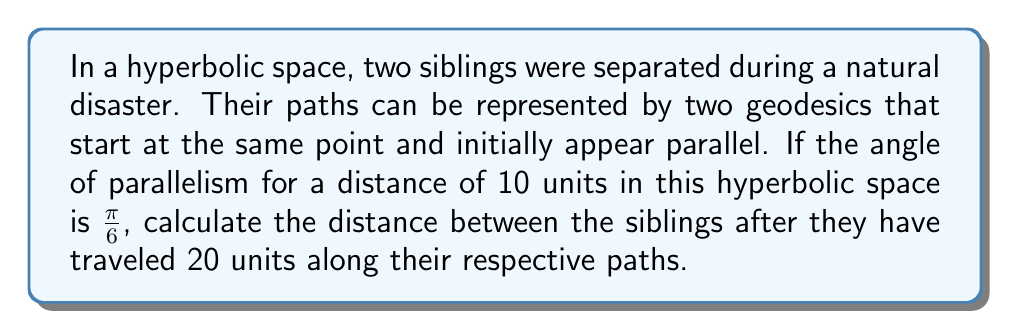Can you answer this question? Let's approach this step-by-step:

1) In hyperbolic geometry, the angle of parallelism $\Pi(d)$ for a distance $d$ is given by the formula:

   $$\Pi(d) = 2 \arctan(e^{-d})$$

2) We're given that $\Pi(10) = \frac{\pi}{6}$. Let's use this to find the curvature of our hyperbolic space:

   $$\frac{\pi}{6} = 2 \arctan(e^{-10k})$$

   Where $k$ is the curvature.

3) Solving this equation:

   $$\tan(\frac{\pi}{12}) = e^{-10k}$$
   $$k = -\frac{1}{10} \ln(\tan(\frac{\pi}{12})) \approx 0.11$$

4) Now, we can use the hyperbolic law of cosines to find the distance between the paths after 20 units:

   $$\cosh(d) = \cosh(a)\cosh(b) - \sinh(a)\sinh(b)\cos(C)$$

   Where $d$ is the distance we're looking for, $a$ and $b$ are both 20 (the distance traveled), and $C$ is the angle between the paths.

5) The angle between the paths is twice the angle of parallelism for a distance of 10:

   $$C = 2 \cdot \frac{\pi}{6} = \frac{\pi}{3}$$

6) Plugging these values into the hyperbolic law of cosines:

   $$\cosh(d) = \cosh(20k)\cosh(20k) - \sinh(20k)\sinh(20k)\cos(\frac{\pi}{3})$$

7) Simplifying:

   $$\cosh(d) = \cosh^2(20k) - \sinh^2(20k) \cdot \frac{1}{2}$$
   $$\cosh(d) = \cosh^2(20k) - \frac{1}{2}(\cosh^2(20k) - 1)$$
   $$\cosh(d) = \frac{1}{2}\cosh^2(20k) + \frac{1}{2}$$

8) Using the value of $k$ we found earlier:

   $$\cosh(d) \approx 3.62$$

9) Finally, we can solve for $d$:

   $$d = \text{arccosh}(3.62) \approx 1.95$$
Answer: $1.95$ units 